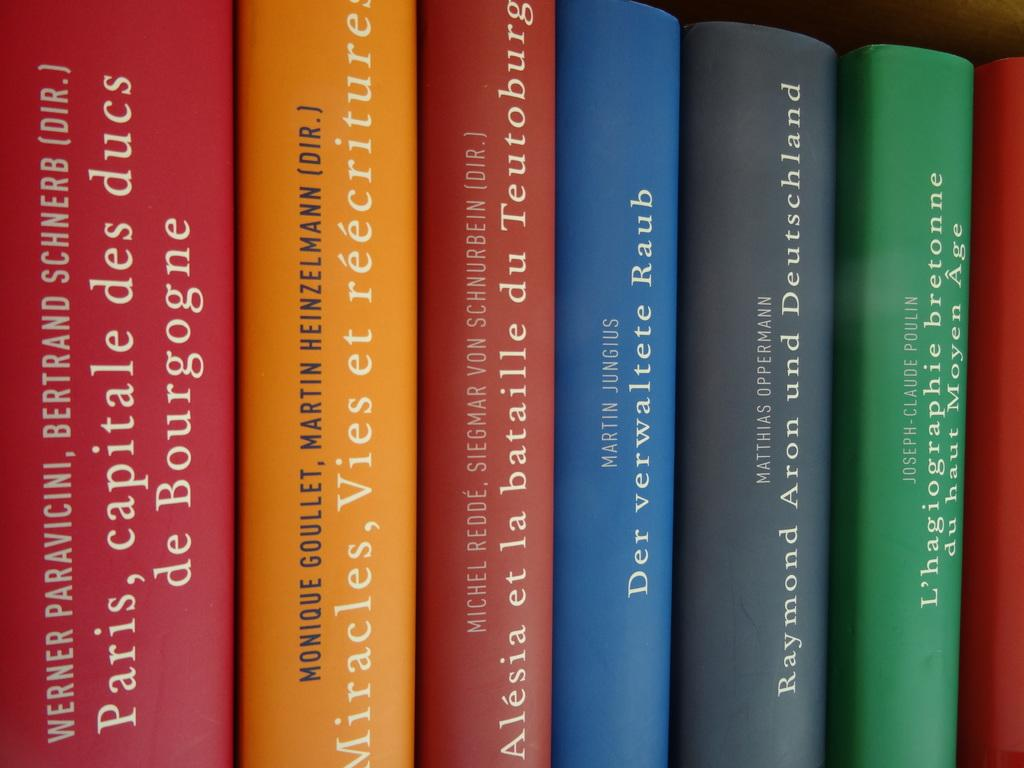<image>
Provide a brief description of the given image. a line of different colored bookcs with the middle one written by martin jungus 